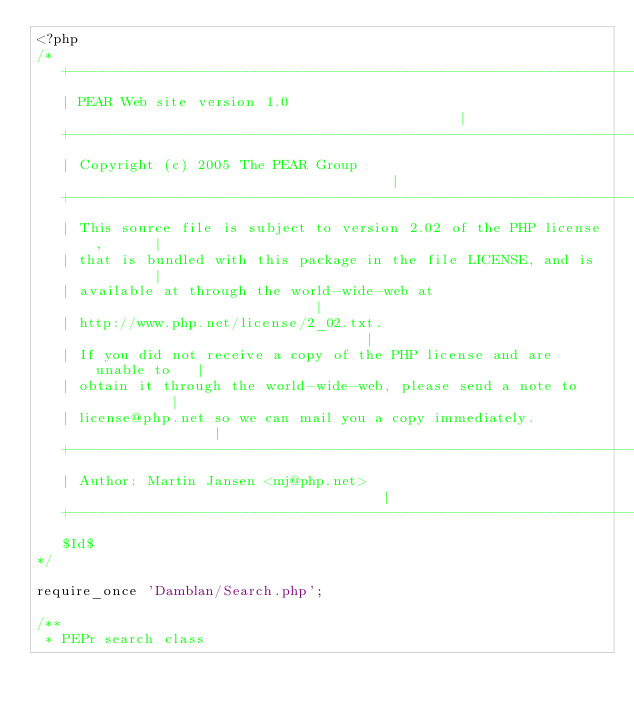<code> <loc_0><loc_0><loc_500><loc_500><_PHP_><?php
/*
   +----------------------------------------------------------------------+
   | PEAR Web site version 1.0                                            |
   +----------------------------------------------------------------------+
   | Copyright (c) 2005 The PEAR Group                                    |
   +----------------------------------------------------------------------+
   | This source file is subject to version 2.02 of the PHP license,      |
   | that is bundled with this package in the file LICENSE, and is        |
   | available at through the world-wide-web at                           |
   | http://www.php.net/license/2_02.txt.                                 |
   | If you did not receive a copy of the PHP license and are unable to   |
   | obtain it through the world-wide-web, please send a note to          |
   | license@php.net so we can mail you a copy immediately.               |
   +----------------------------------------------------------------------+
   | Author: Martin Jansen <mj@php.net>                                   |
   +----------------------------------------------------------------------+
   $Id$
*/

require_once 'Damblan/Search.php';

/**
 * PEPr search class</code> 